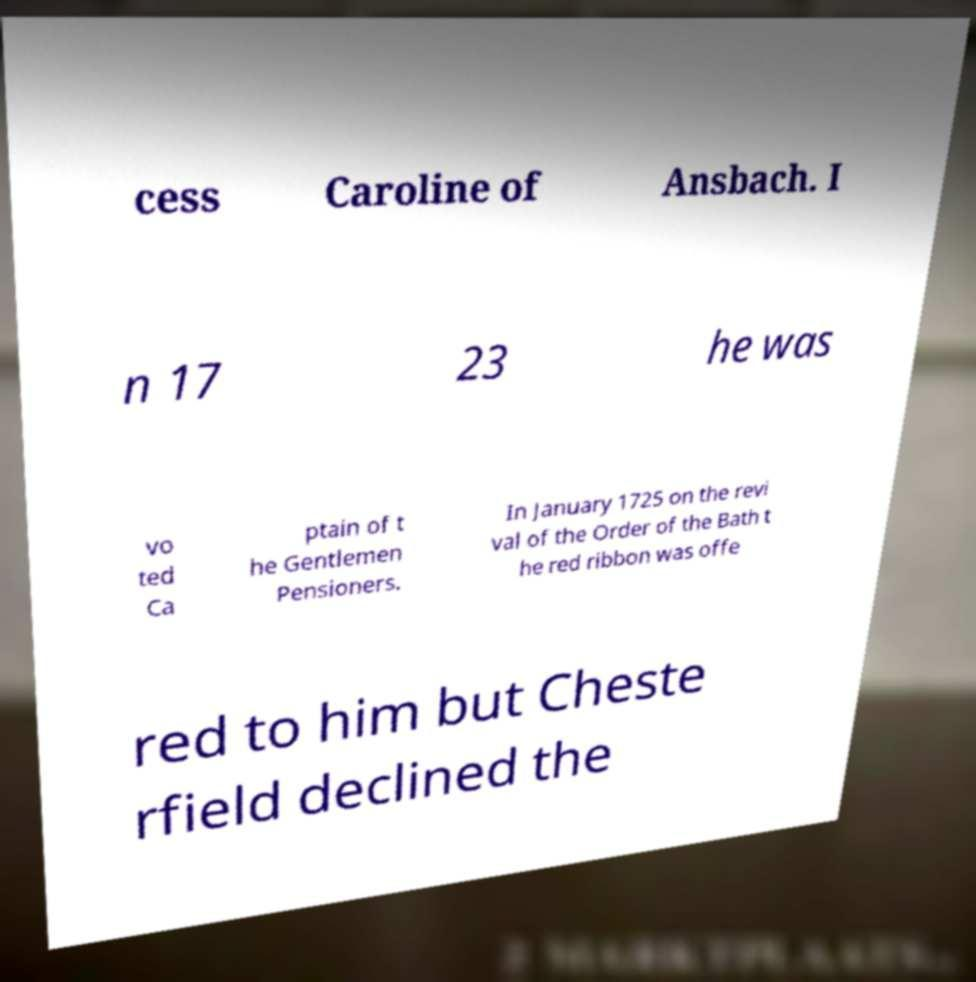Can you read and provide the text displayed in the image?This photo seems to have some interesting text. Can you extract and type it out for me? cess Caroline of Ansbach. I n 17 23 he was vo ted Ca ptain of t he Gentlemen Pensioners. In January 1725 on the revi val of the Order of the Bath t he red ribbon was offe red to him but Cheste rfield declined the 